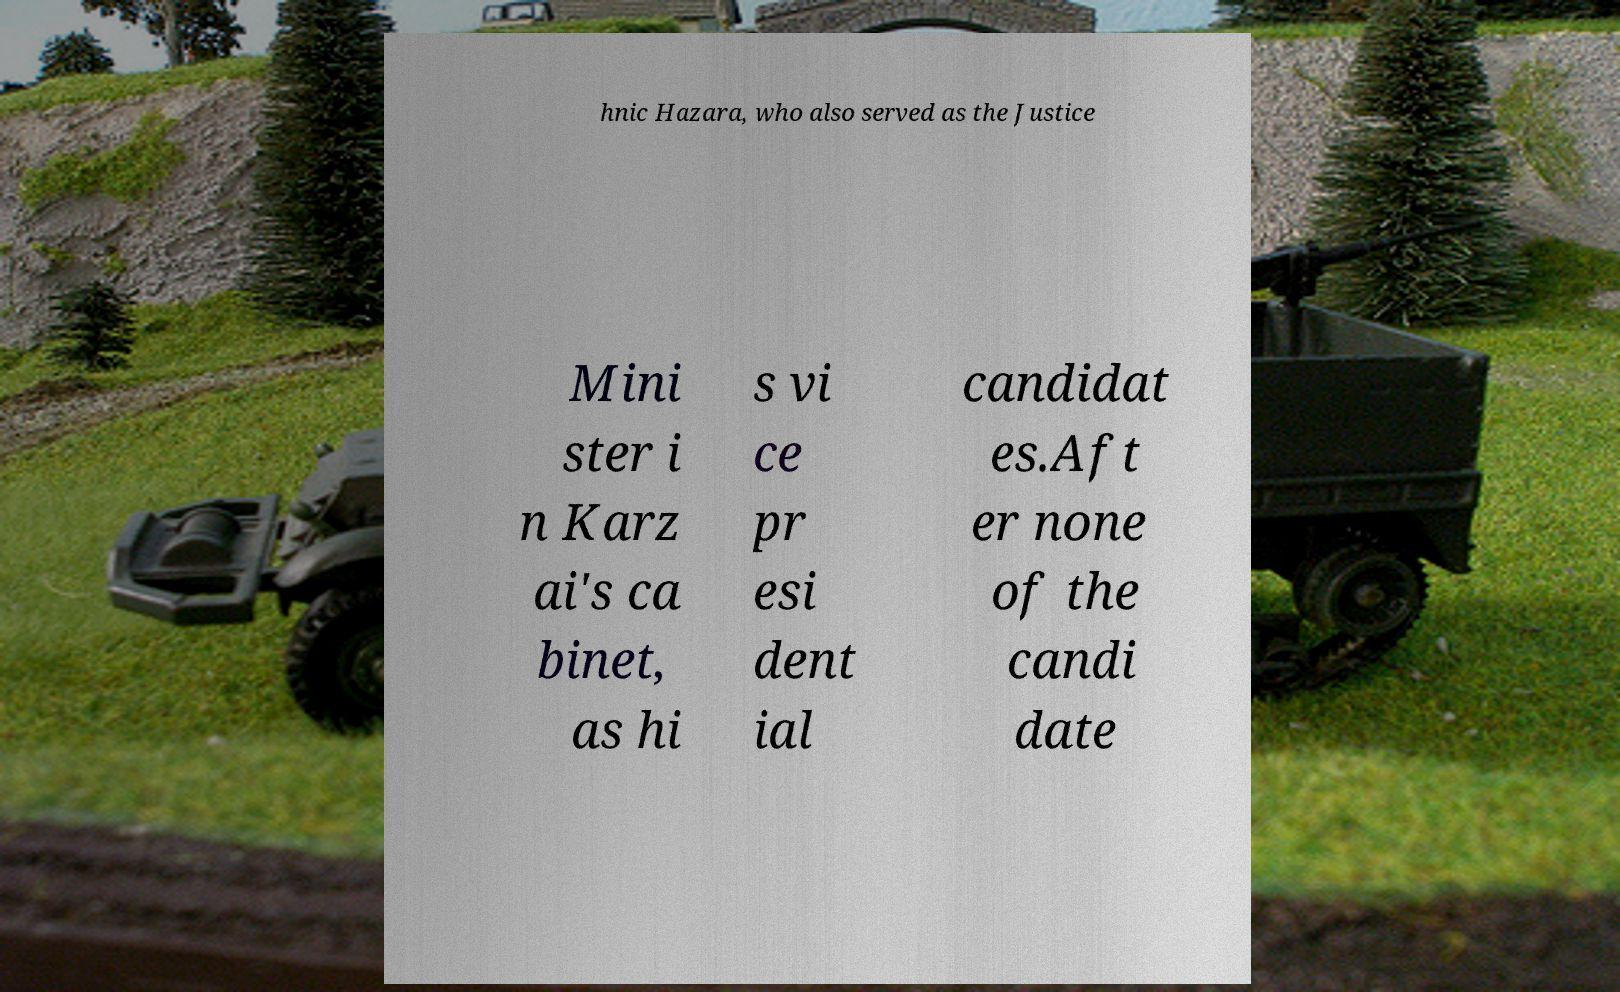Could you assist in decoding the text presented in this image and type it out clearly? hnic Hazara, who also served as the Justice Mini ster i n Karz ai's ca binet, as hi s vi ce pr esi dent ial candidat es.Aft er none of the candi date 